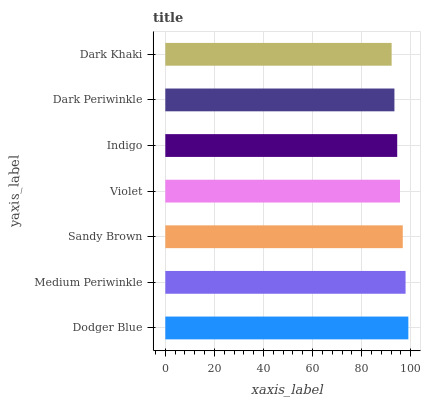Is Dark Khaki the minimum?
Answer yes or no. Yes. Is Dodger Blue the maximum?
Answer yes or no. Yes. Is Medium Periwinkle the minimum?
Answer yes or no. No. Is Medium Periwinkle the maximum?
Answer yes or no. No. Is Dodger Blue greater than Medium Periwinkle?
Answer yes or no. Yes. Is Medium Periwinkle less than Dodger Blue?
Answer yes or no. Yes. Is Medium Periwinkle greater than Dodger Blue?
Answer yes or no. No. Is Dodger Blue less than Medium Periwinkle?
Answer yes or no. No. Is Violet the high median?
Answer yes or no. Yes. Is Violet the low median?
Answer yes or no. Yes. Is Dodger Blue the high median?
Answer yes or no. No. Is Dodger Blue the low median?
Answer yes or no. No. 